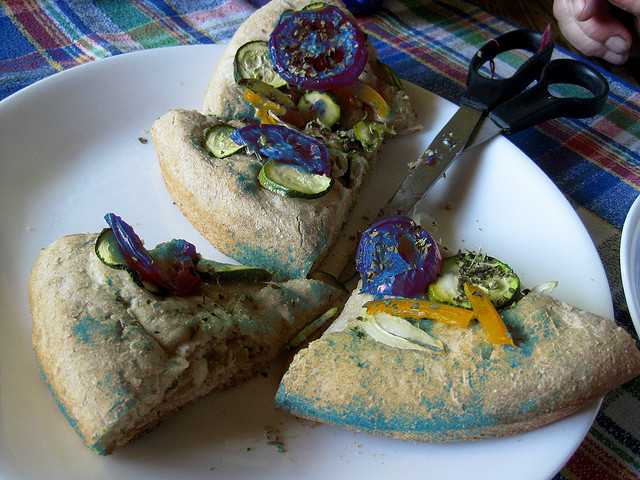<image>What utensil is in this picture? I am not certain. The utensil in the picture can either be scissors or shears. What utensil is in this picture? The utensil in the picture is scissors. 